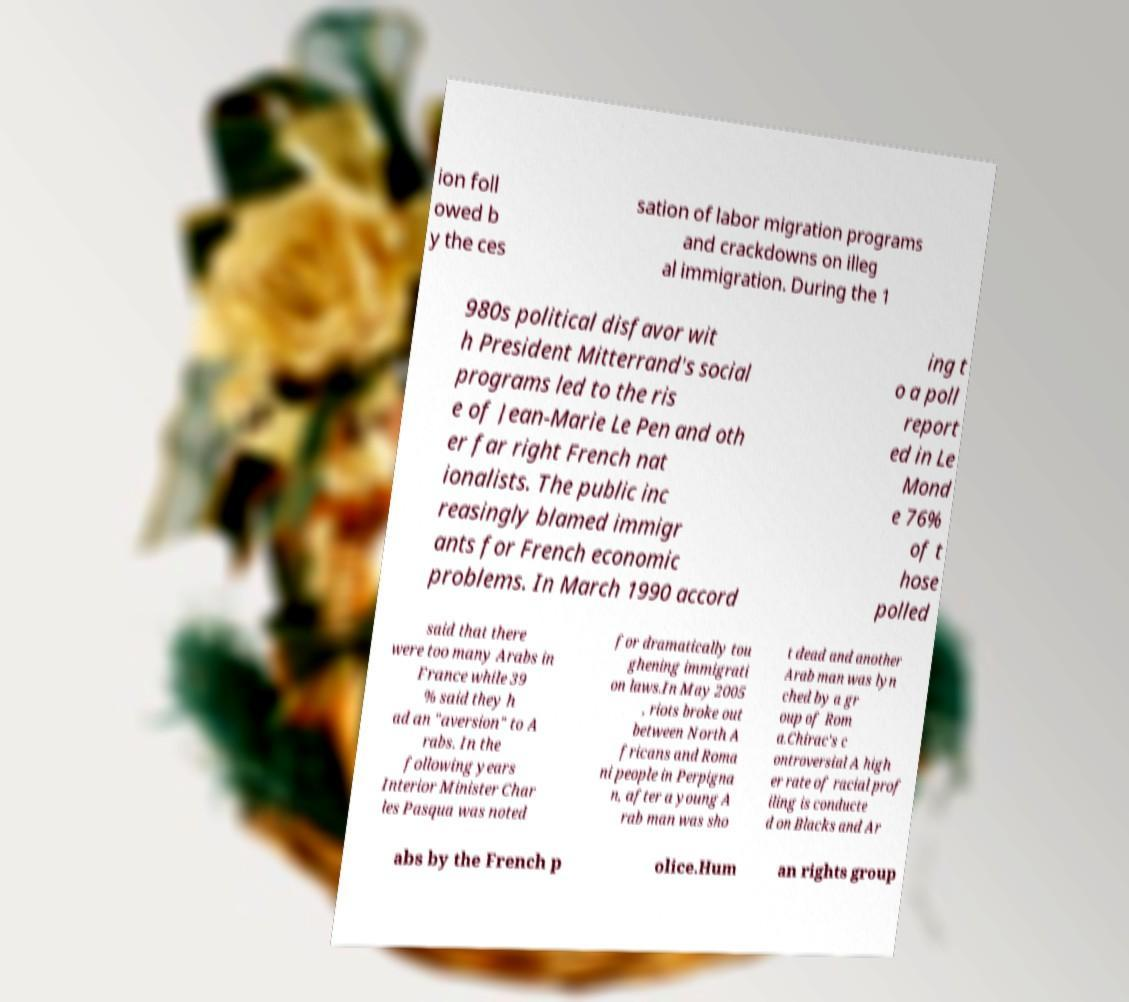Can you accurately transcribe the text from the provided image for me? ion foll owed b y the ces sation of labor migration programs and crackdowns on illeg al immigration. During the 1 980s political disfavor wit h President Mitterrand's social programs led to the ris e of Jean-Marie Le Pen and oth er far right French nat ionalists. The public inc reasingly blamed immigr ants for French economic problems. In March 1990 accord ing t o a poll report ed in Le Mond e 76% of t hose polled said that there were too many Arabs in France while 39 % said they h ad an "aversion" to A rabs. In the following years Interior Minister Char les Pasqua was noted for dramatically tou ghening immigrati on laws.In May 2005 , riots broke out between North A fricans and Roma ni people in Perpigna n, after a young A rab man was sho t dead and another Arab man was lyn ched by a gr oup of Rom a.Chirac's c ontroversial A high er rate of racial prof iling is conducte d on Blacks and Ar abs by the French p olice.Hum an rights group 